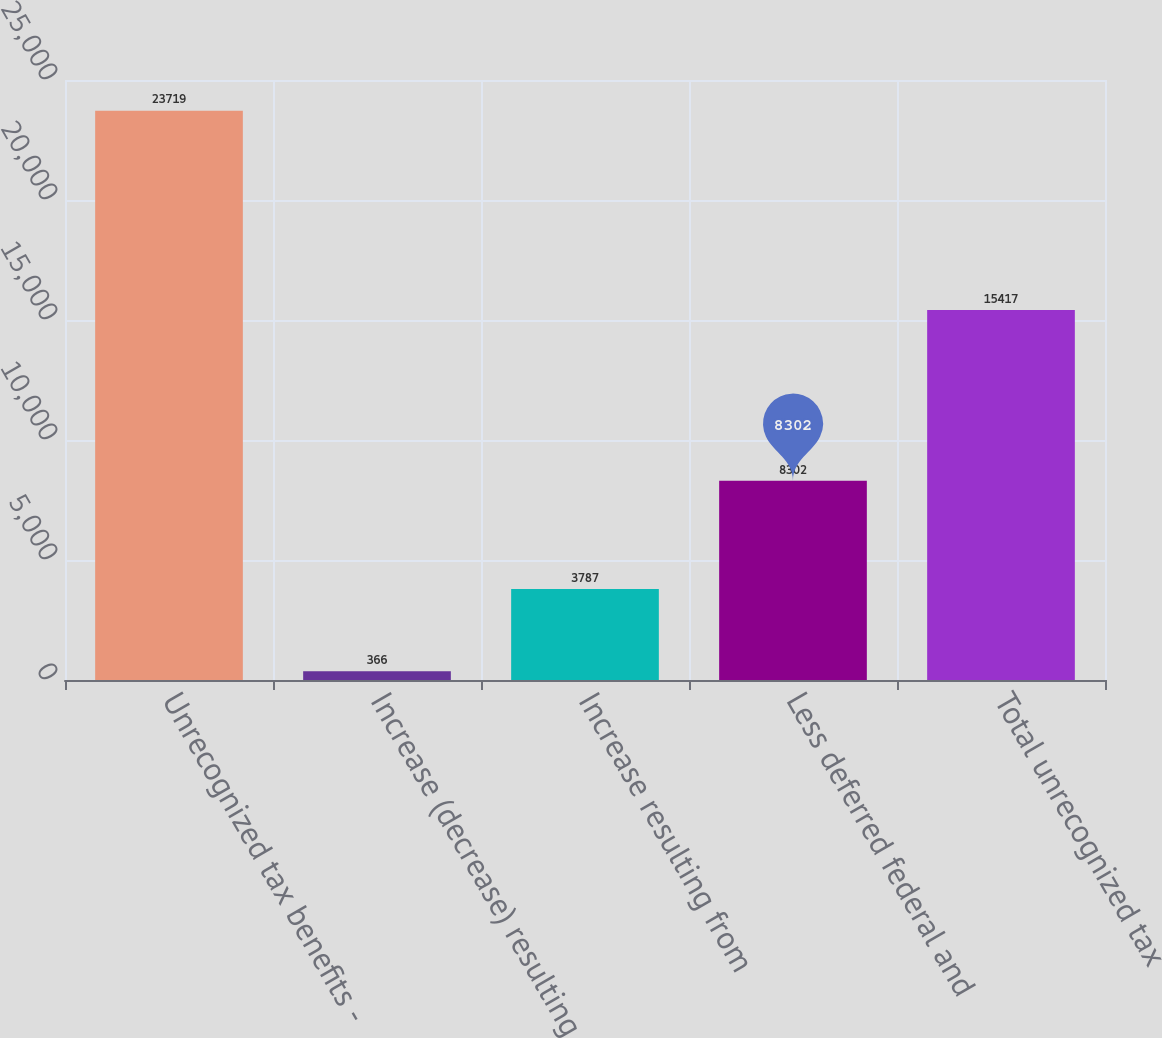Convert chart to OTSL. <chart><loc_0><loc_0><loc_500><loc_500><bar_chart><fcel>Unrecognized tax benefits -<fcel>Increase (decrease) resulting<fcel>Increase resulting from<fcel>Less deferred federal and<fcel>Total unrecognized tax<nl><fcel>23719<fcel>366<fcel>3787<fcel>8302<fcel>15417<nl></chart> 